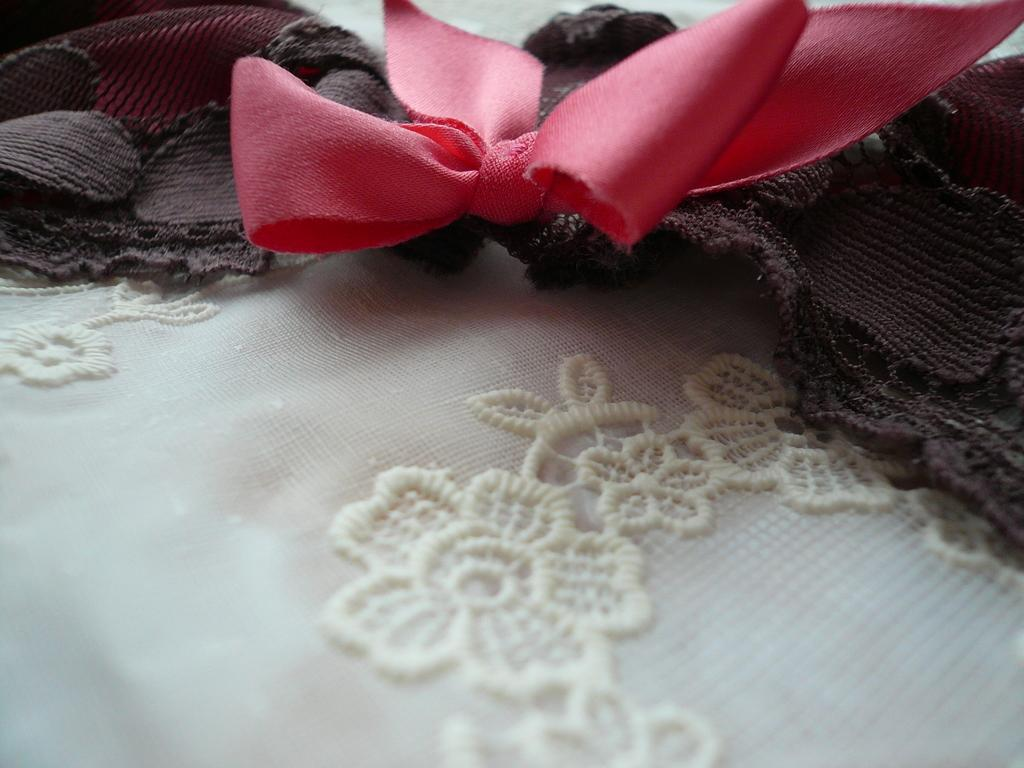What type of design can be seen on the white fabric in the image? There is a floral design on the white fabric in the image. What is the color of the knitted fabric in the image? The knitted fabric in the image is pink. What is the color of the fabric at the bottom of the image? The fabric at the bottom of the image is brown. What type of territory is depicted in the image? There is no territory depicted in the image; it features fabrics with different designs and colors. Can you describe the downtown area in the image? There is no downtown area depicted in the image; it features fabrics with different designs and colors. 